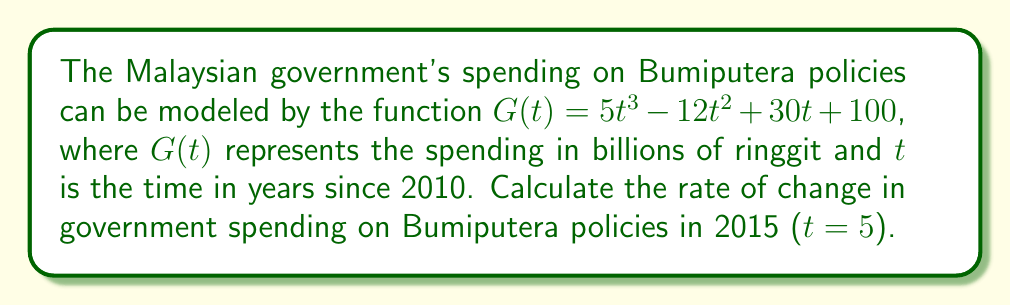Could you help me with this problem? To find the rate of change in government spending, we need to calculate the derivative of the given function $G(t)$ and then evaluate it at $t = 5$.

Step 1: Find the derivative of $G(t)$
$$G(t) = 5t^3 - 12t^2 + 30t + 100$$
$$G'(t) = 15t^2 - 24t + 30$$

Step 2: Evaluate $G'(t)$ at $t = 5$
$$G'(5) = 15(5)^2 - 24(5) + 30$$
$$G'(5) = 15(25) - 120 + 30$$
$$G'(5) = 375 - 120 + 30$$
$$G'(5) = 285$$

The rate of change in 2015 is 285 billion ringgit per year.
Answer: 285 billion ringgit/year 